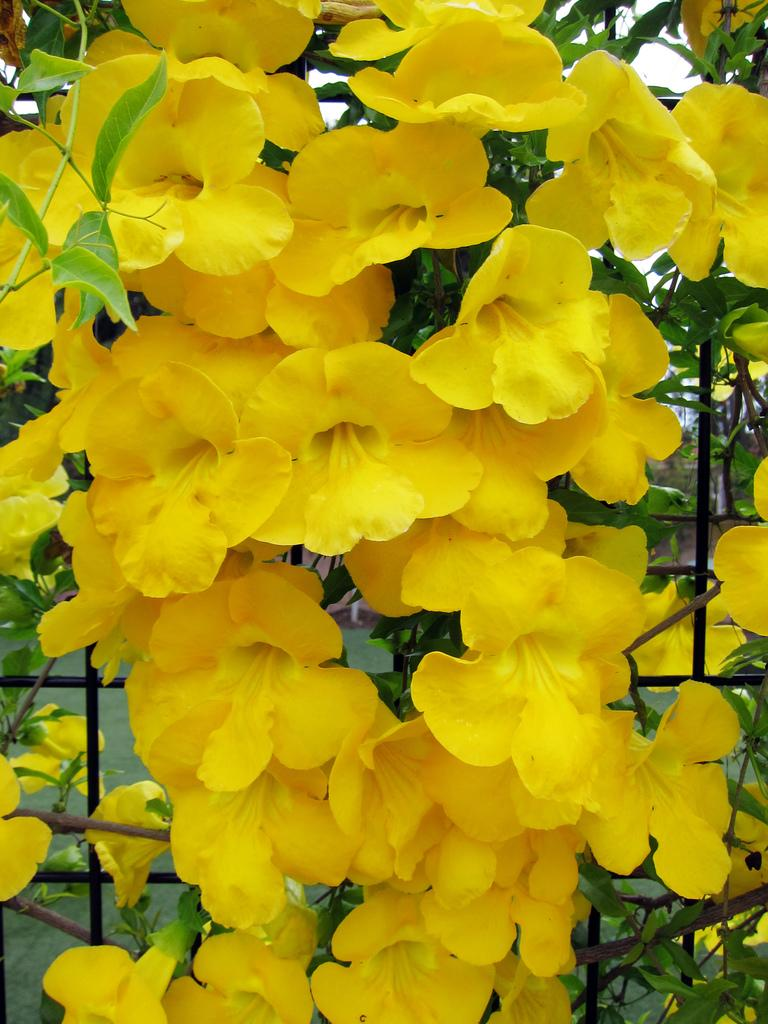What type of plants can be seen in the image? The image contains flowers. What type of structure is present in the image? There is fencing in the image. What parts of the flowers are visible in the image? The image includes stems and leaves. What can be seen in the background of the image? There is grass in the background of the image. What type of pain is the horse experiencing in the image? There is no horse present in the image, so it is not possible to determine if a horse is experiencing any pain. 